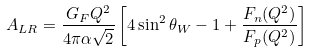Convert formula to latex. <formula><loc_0><loc_0><loc_500><loc_500>A _ { L R } = \frac { G _ { F } Q ^ { 2 } } { 4 \pi \alpha \sqrt { 2 } } \left [ 4 \sin ^ { 2 } \theta _ { W } - 1 + \frac { F _ { n } ( Q ^ { 2 } ) } { F _ { p } ( Q ^ { 2 } ) } \right ]</formula> 